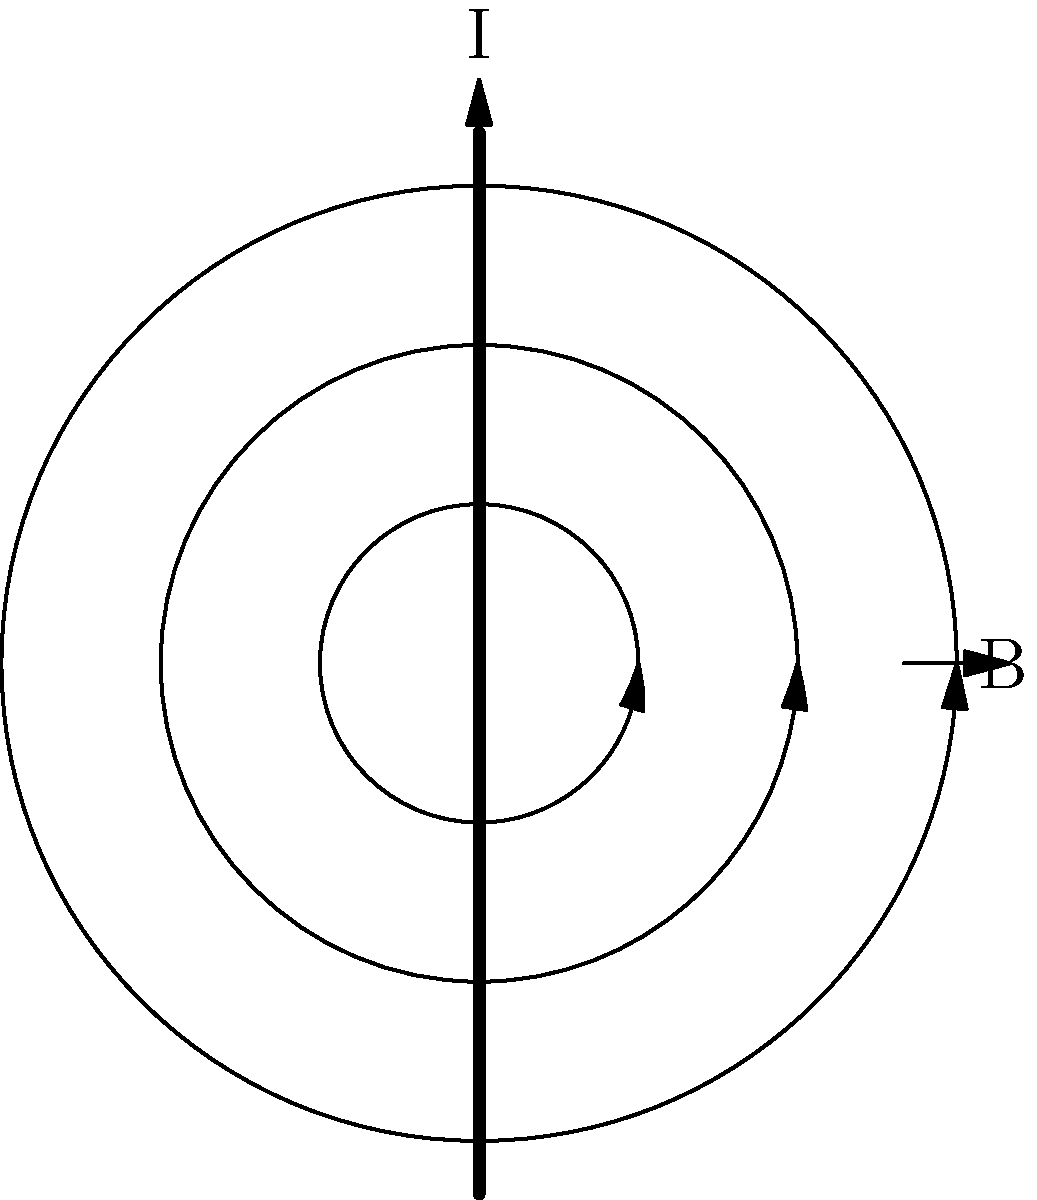As a journalist covering a story on electromagnetic technologies, you encounter a diagram showing a current-carrying wire. The current flows upward, and circular magnetic field lines surround the wire. How would the direction of the magnetic field change if the current direction were reversed, and what principle explains this relationship? To answer this question, let's break it down step-by-step:

1. Current direction and magnetic field:
   - In the given diagram, the current (I) flows upward in the wire.
   - The magnetic field lines (B) form concentric circles around the wire.
   - The direction of the magnetic field is clockwise when viewed from above.

2. Right-hand rule:
   - The relationship between current and magnetic field is governed by the right-hand rule.
   - Point your right thumb in the direction of the current.
   - Your fingers will curl in the direction of the magnetic field.

3. Reversing the current:
   - If the current direction is reversed (downward), we need to apply the right-hand rule again.
   - With the thumb pointing downward, the fingers would curl in the opposite direction.
   - This means the magnetic field direction would reverse from clockwise to counterclockwise.

4. Underlying principle:
   - This relationship is explained by Ampère's Law, which states that a current-carrying wire produces a magnetic field circulating around it.
   - The direction of this field is determined by the direction of the current.
   - Mathematically, this is expressed as:
     $$\oint \mathbf{B} \cdot d\mathbf{l} = \mu_0 I$$
     where $\mathbf{B}$ is the magnetic field, $d\mathbf{l}$ is an infinitesimal length element of the loop, $\mu_0$ is the permeability of free space, and $I$ is the current.

5. Conclusion:
   - Reversing the current direction will reverse the direction of the magnetic field.
   - This is a direct application of Ampère's Law and the right-hand rule.
Answer: The magnetic field direction would reverse (counterclockwise), as explained by Ampère's Law and the right-hand rule. 